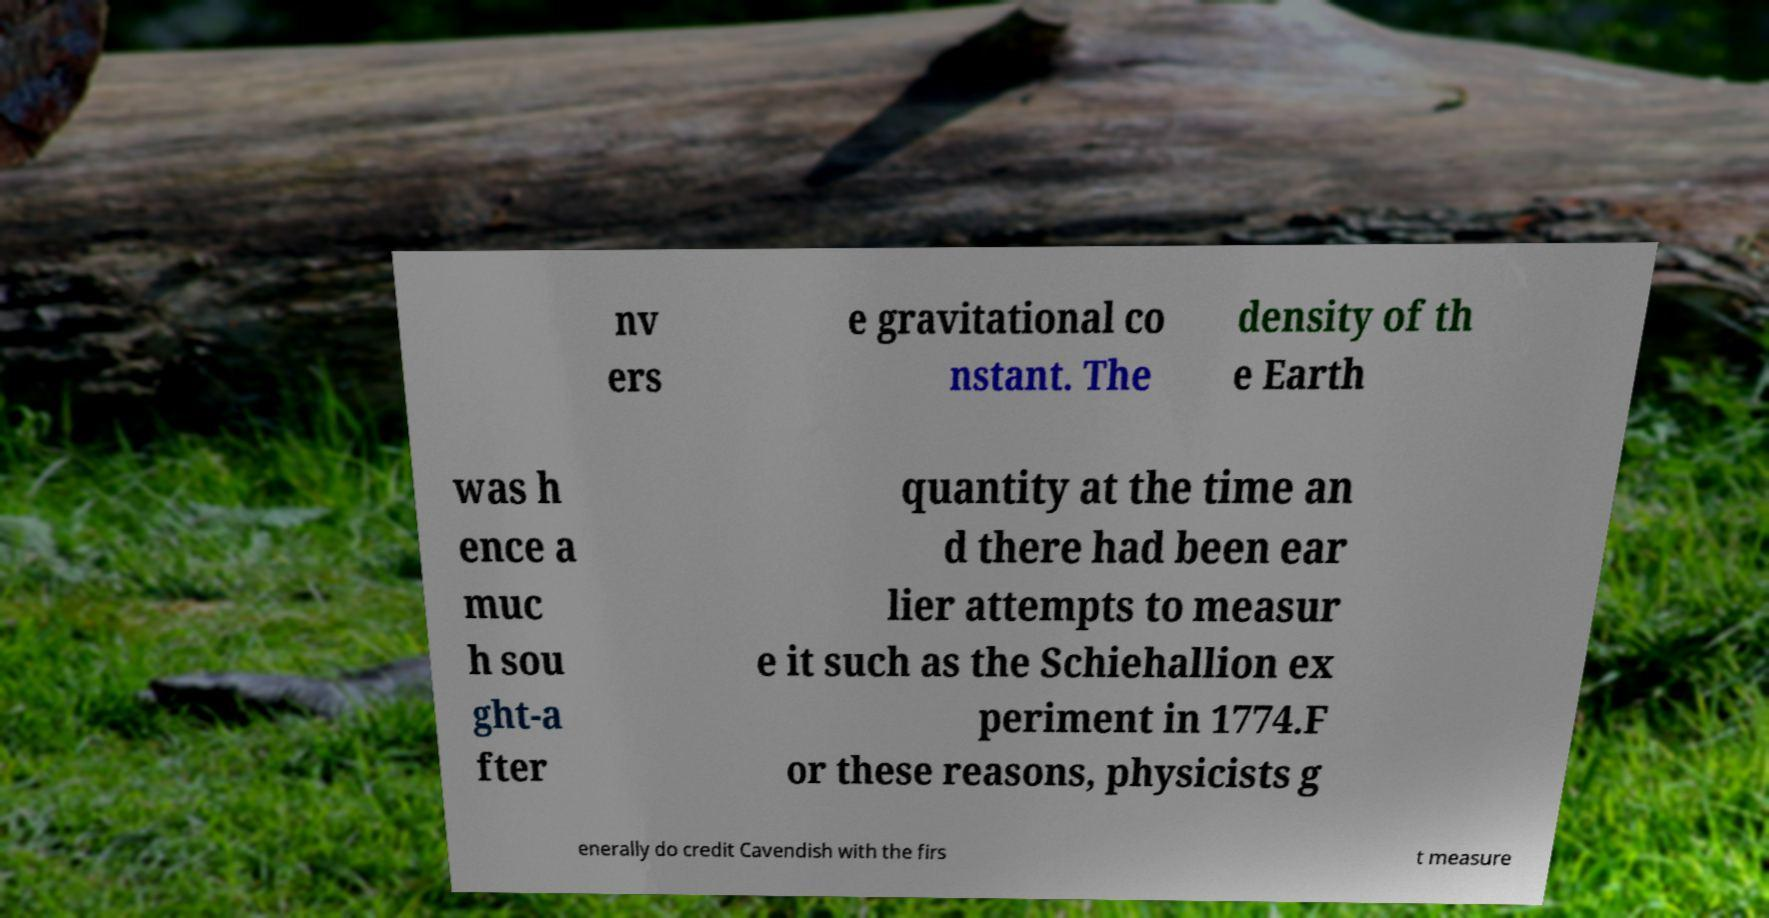Please identify and transcribe the text found in this image. nv ers e gravitational co nstant. The density of th e Earth was h ence a muc h sou ght-a fter quantity at the time an d there had been ear lier attempts to measur e it such as the Schiehallion ex periment in 1774.F or these reasons, physicists g enerally do credit Cavendish with the firs t measure 